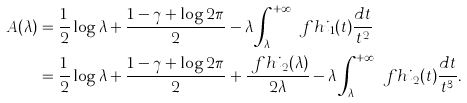<formula> <loc_0><loc_0><loc_500><loc_500>A ( \lambda ) & = \frac { 1 } { 2 } \log \lambda + \frac { 1 - \gamma + \log 2 \pi } { 2 } - \lambda \int _ { \lambda } ^ { + \infty } \ f h i _ { 1 } ( t ) \frac { d t } { t ^ { 2 } } \\ & = \frac { 1 } { 2 } \log \lambda + \frac { 1 - \gamma + \log 2 \pi } { 2 } + \frac { \ f h i _ { 2 } ( \lambda ) } { 2 \lambda } - \lambda \int _ { \lambda } ^ { + \infty } \ f h i _ { 2 } ( t ) \frac { d t } { t ^ { 3 } } .</formula> 